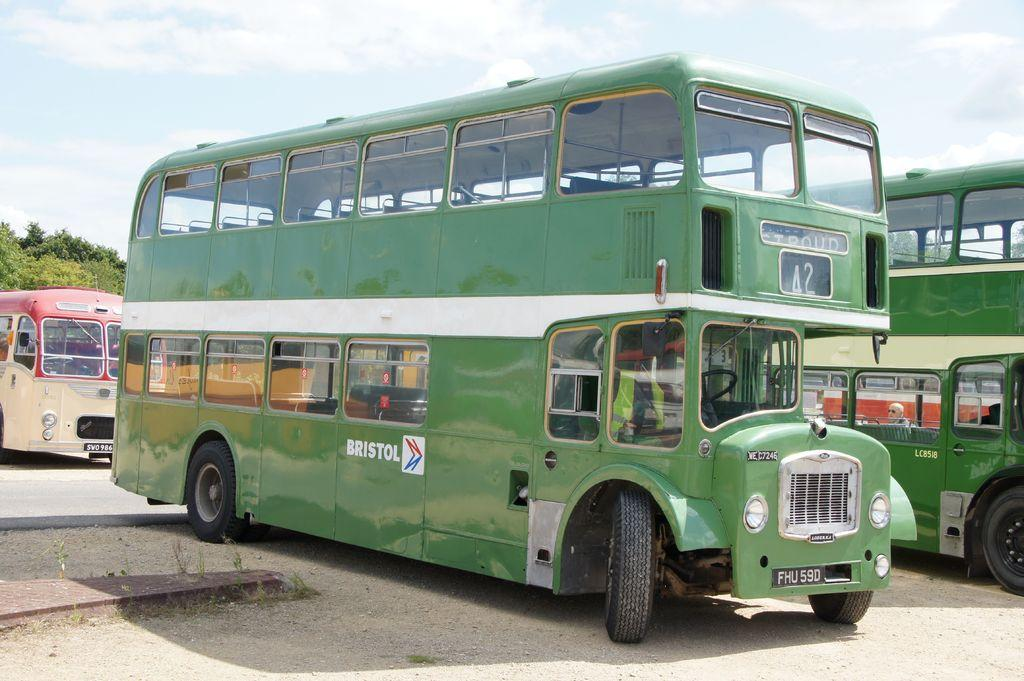<image>
Offer a succinct explanation of the picture presented. A green double Decker bus has the word Bristol painted on the side. 